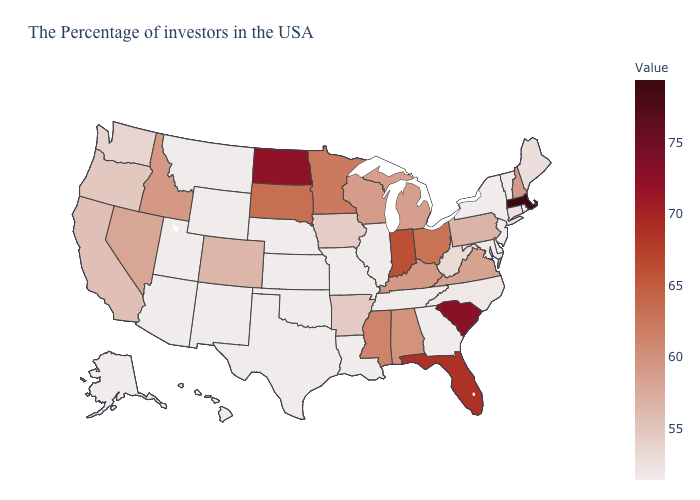Is the legend a continuous bar?
Short answer required. Yes. Which states hav the highest value in the MidWest?
Keep it brief. North Dakota. Which states have the highest value in the USA?
Give a very brief answer. Massachusetts. Among the states that border Indiana , which have the lowest value?
Short answer required. Illinois. Among the states that border Florida , which have the highest value?
Be succinct. Alabama. Does Rhode Island have the lowest value in the USA?
Be succinct. Yes. Among the states that border Kansas , does Colorado have the highest value?
Be succinct. Yes. 